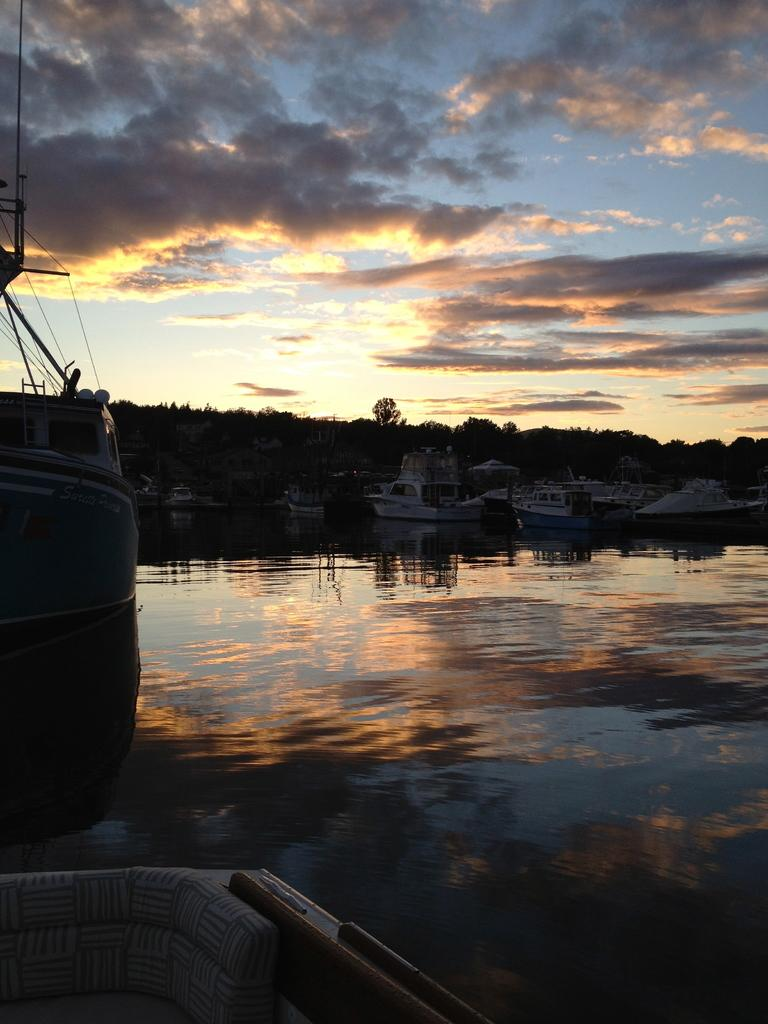What is positioned above the water in the image? There are boats above the water in the image. What can be seen on the water's surface in the image? There are reflections on the water in the image. What type of vegetation is visible in the background of the image? There are trees visible in the background of the image. What is the condition of the sky in the background of the image? The sky appears to be cloudy in the background of the image. What color is the crayon used to draw the boats in the image? There is no crayon present in the image; it is a photograph or illustration of actual boats. How is the hose connected to the boats in the image? There is no hose present in the image; it features boats above the water and reflections on the water's surface. 